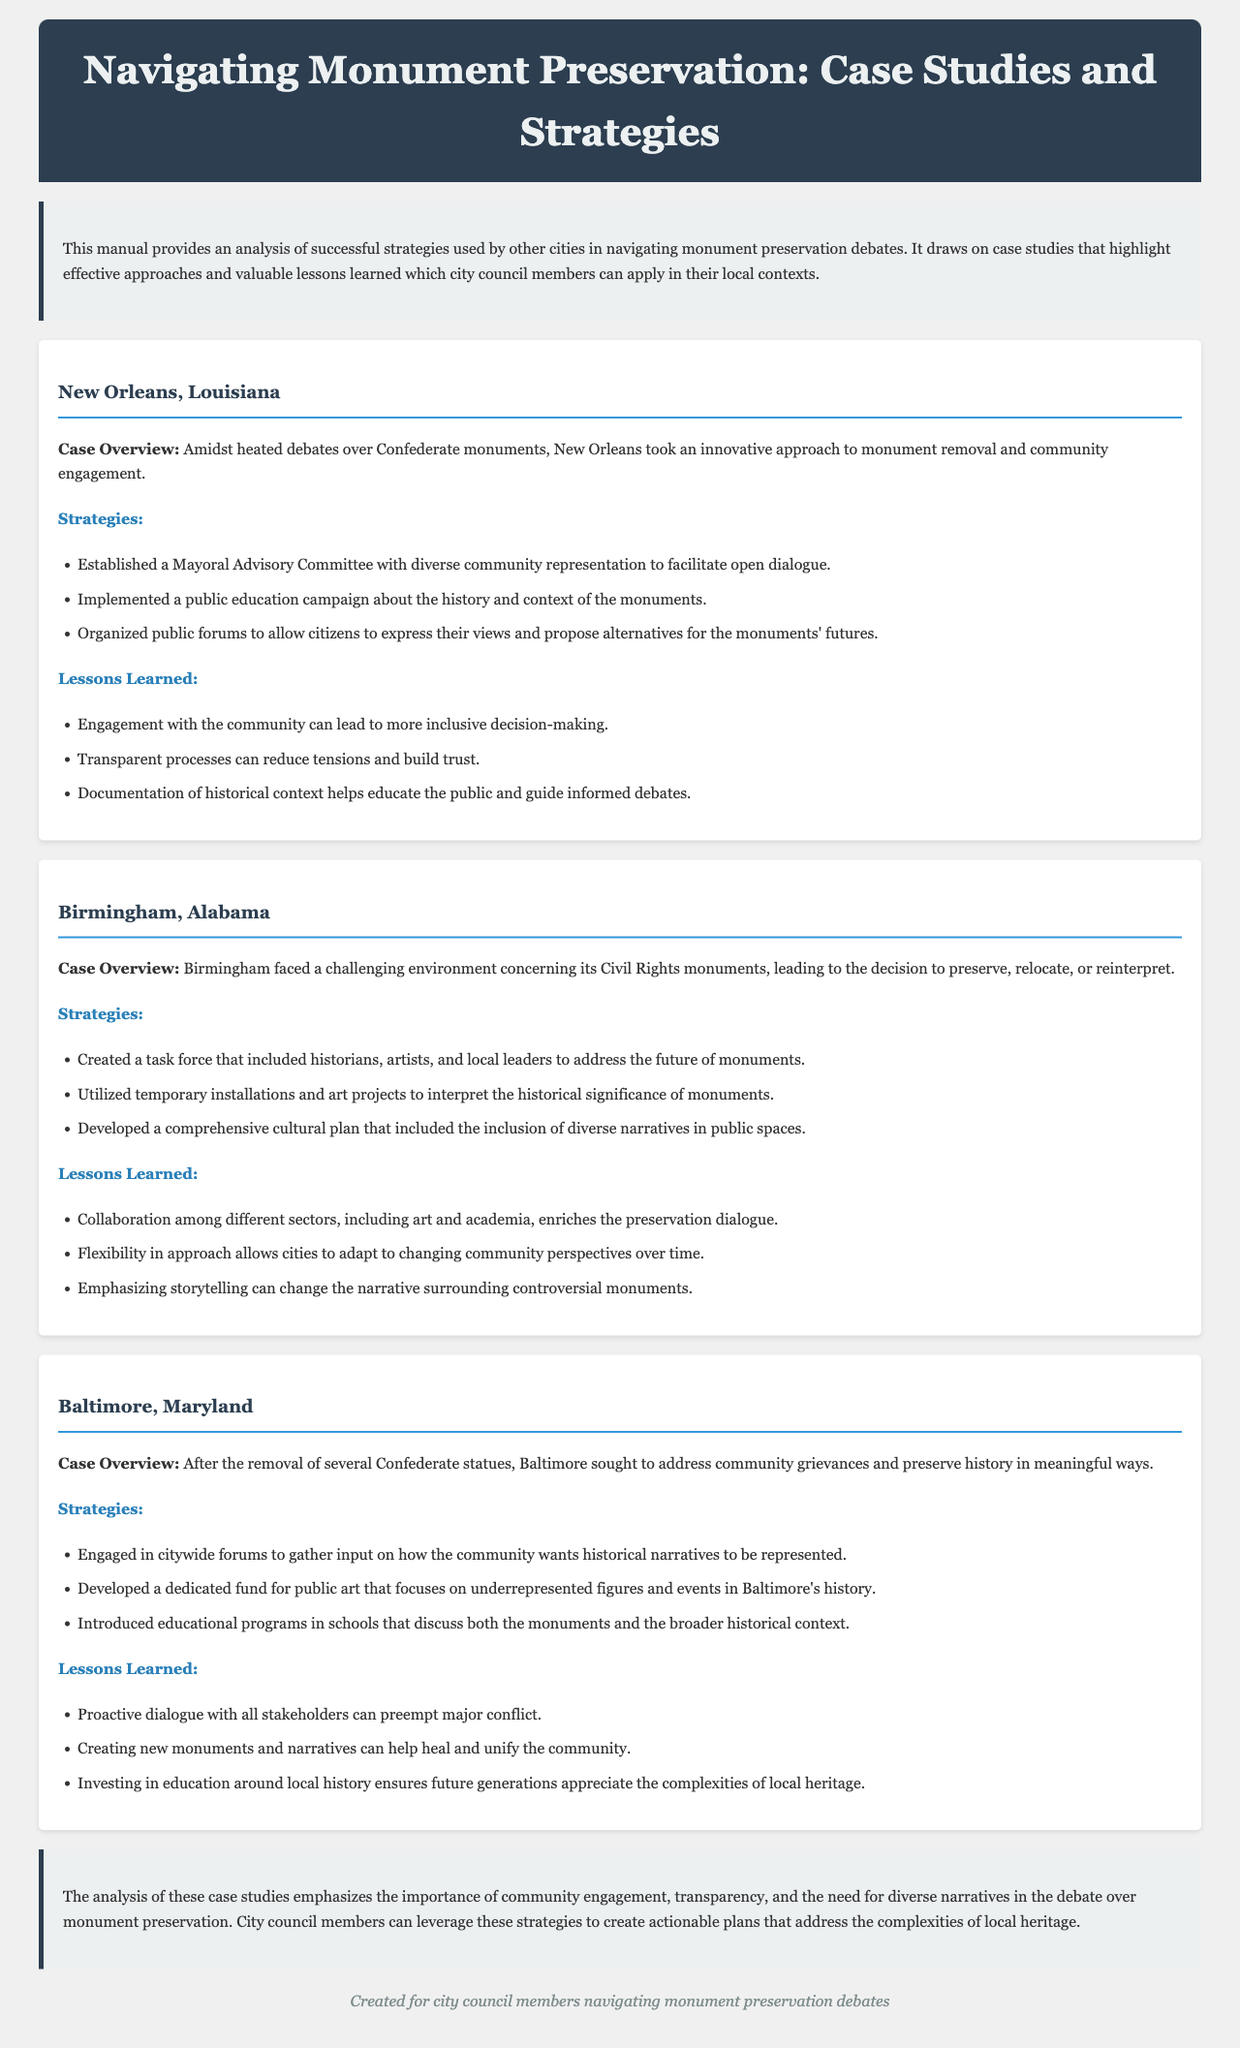What is the main purpose of this manual? The main purpose of the manual is to provide an analysis of successful strategies used by other cities in navigating monument preservation debates.
Answer: Analysis of successful strategies Which city utilized a Mayoral Advisory Committee for monument discussions? The case study mentions that New Orleans established a Mayoral Advisory Committee for community representation.
Answer: New Orleans What type of task force was created in Birmingham? Birmingham created a task force that included historians, artists, and local leaders.
Answer: Task force What is one lesson learned from the Baltimore case study? One lesson learned is that creating new monuments and narratives can help heal and unify the community.
Answer: Creating new monuments Which city implemented a public education campaign about its monuments? New Orleans implemented a public education campaign about the history and context of the monuments.
Answer: New Orleans What does the conclusion emphasize as important in monument preservation debates? The conclusion emphasizes the importance of community engagement, transparency, and diverse narratives.
Answer: Community engagement, transparency, diverse narratives 